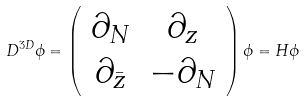<formula> <loc_0><loc_0><loc_500><loc_500>D ^ { 3 D } \phi = \left ( \begin{array} { c c } \partial _ { N } & \partial _ { z } \\ \partial _ { \bar { z } } & - \partial _ { N } \end{array} \right ) \phi = H \phi</formula> 